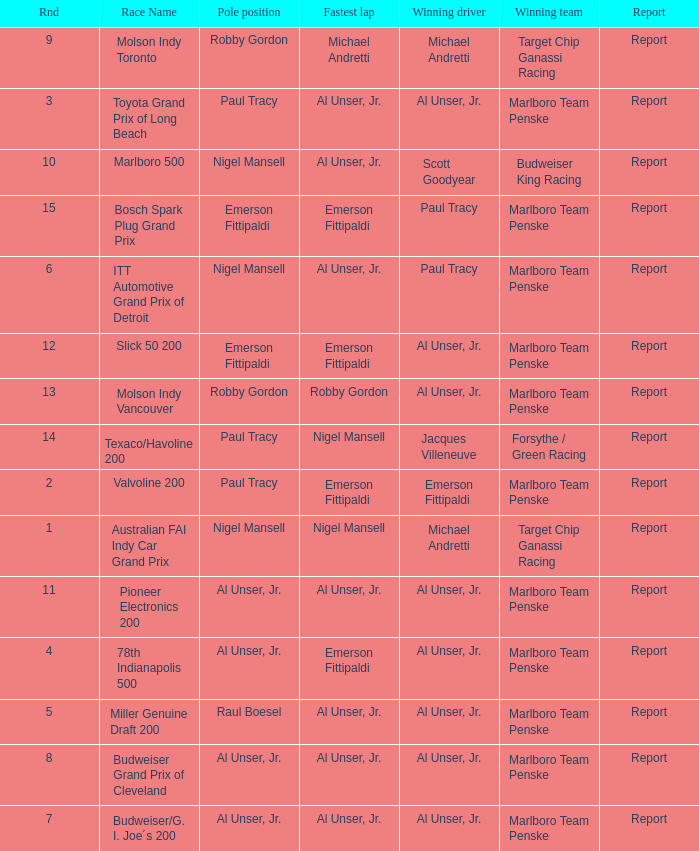Who was on the pole position in the Texaco/Havoline 200 race? Paul Tracy. 